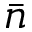<formula> <loc_0><loc_0><loc_500><loc_500>\bar { n }</formula> 